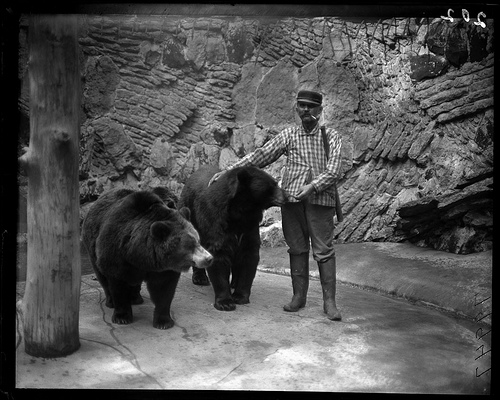Which bear is wearing a striped sweater? Upon closer inspection, none of the bears in the image are wearing any clothing, including striped sweaters. You can see each bear's fur clearly, with distinctive textures that give them a natural look, making the scene more about their natural state. 